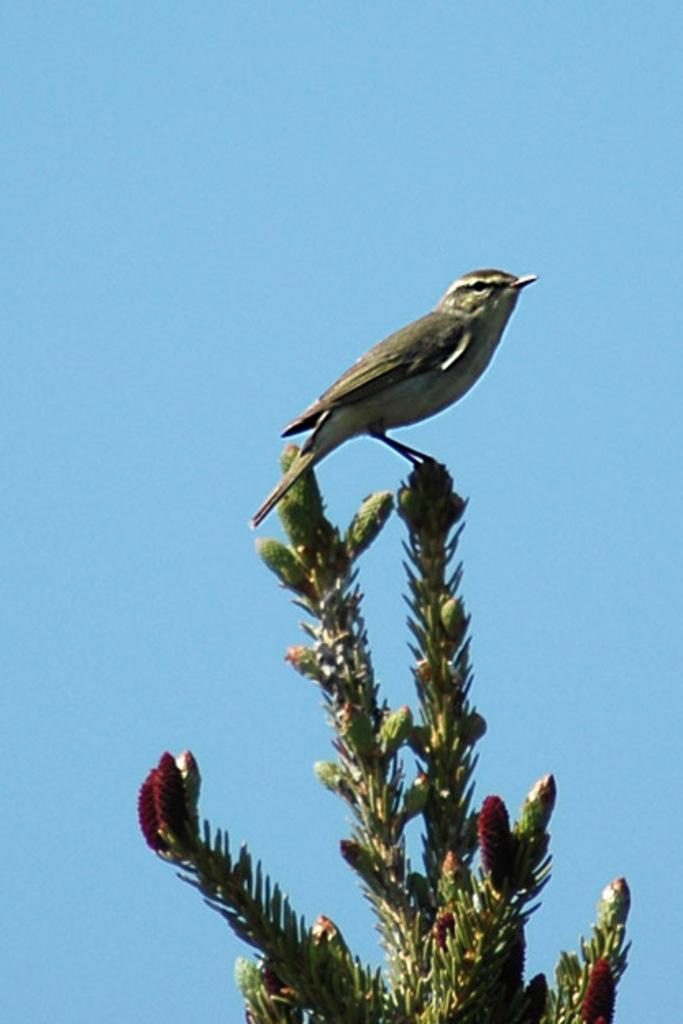What type of animal can be seen in the image? There is a bird in the image. Where is the bird located? The bird is on a plant. What can be seen in the background of the image? The sky is visible in the background of the image. What type of crate is the bird using to fly in the image? There is no crate present in the image, and the bird is not using any object to fly. 